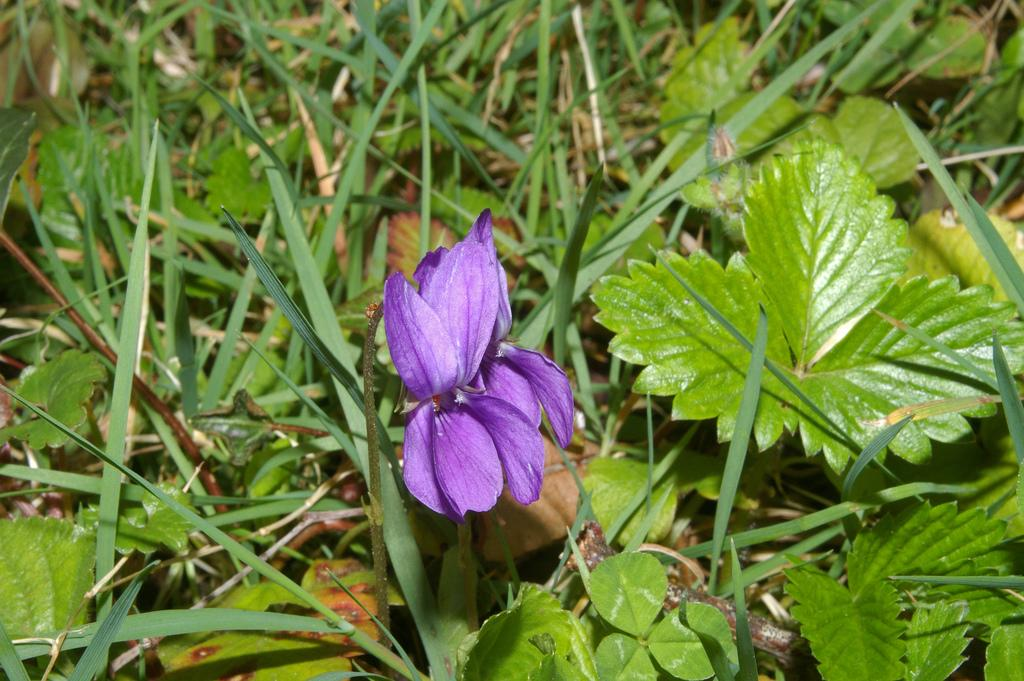What is the main subject of the image? There is a purple flower in the center of the image. What other plants can be seen in the image? There are small plants around the area of the image. How much profit did the vacation generate for the balls in the image? There is no mention of profit, vacation, or balls in the image. The image only features a purple flower and small plants. 